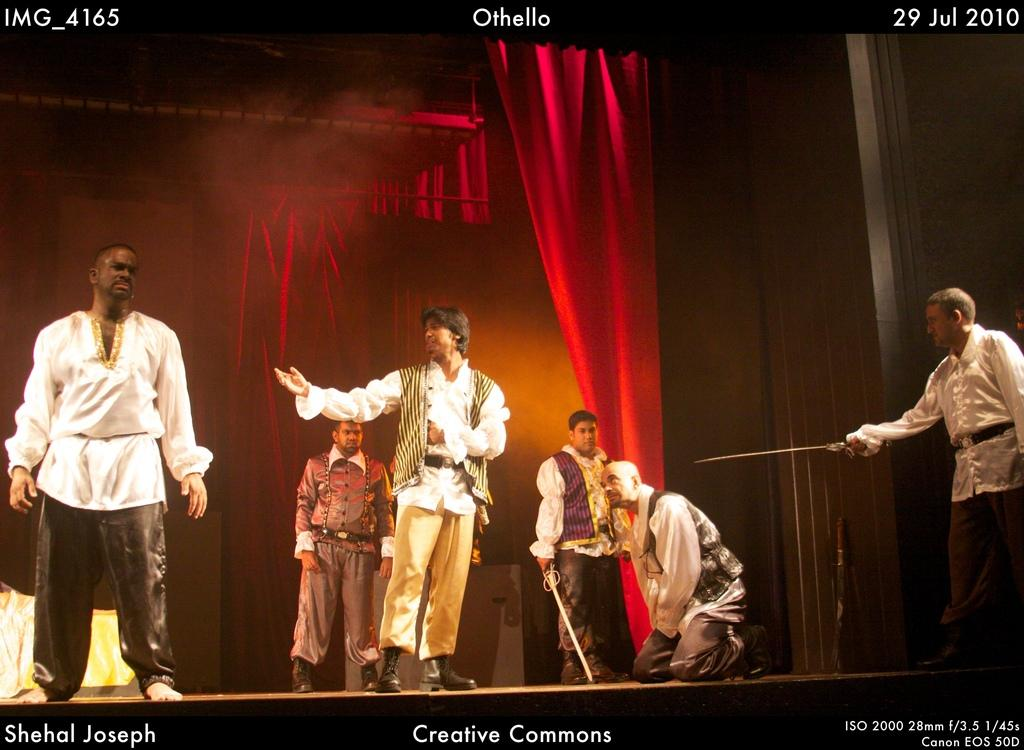How many men are on stage in the image? There are six men on stage in the image. What are two of the men holding? Two of the men are holding swords. What can be seen in the background of the image? There are curtains, objects, and text visible in the background of the image. How many clovers are on stage in the image? There are no clovers present in the image; it features six men on stage. What type of store is visible in the background of the image? There is no store visible in the background of the image. 